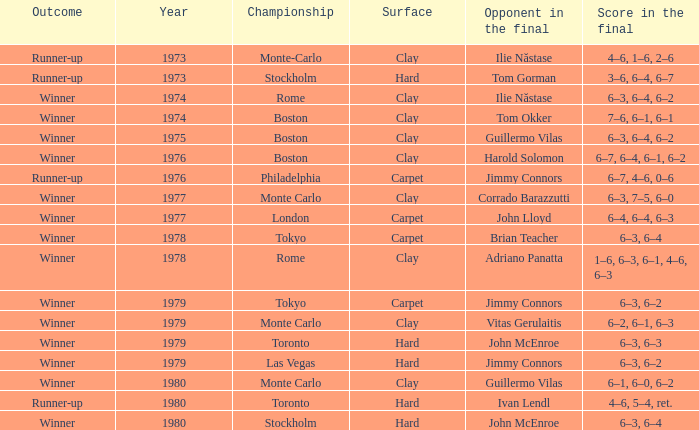Name the championship for clay and corrado barazzutti Monte Carlo. Help me parse the entirety of this table. {'header': ['Outcome', 'Year', 'Championship', 'Surface', 'Opponent in the final', 'Score in the final'], 'rows': [['Runner-up', '1973', 'Monte-Carlo', 'Clay', 'Ilie Năstase', '4–6, 1–6, 2–6'], ['Runner-up', '1973', 'Stockholm', 'Hard', 'Tom Gorman', '3–6, 6–4, 6–7'], ['Winner', '1974', 'Rome', 'Clay', 'Ilie Năstase', '6–3, 6–4, 6–2'], ['Winner', '1974', 'Boston', 'Clay', 'Tom Okker', '7–6, 6–1, 6–1'], ['Winner', '1975', 'Boston', 'Clay', 'Guillermo Vilas', '6–3, 6–4, 6–2'], ['Winner', '1976', 'Boston', 'Clay', 'Harold Solomon', '6–7, 6–4, 6–1, 6–2'], ['Runner-up', '1976', 'Philadelphia', 'Carpet', 'Jimmy Connors', '6–7, 4–6, 0–6'], ['Winner', '1977', 'Monte Carlo', 'Clay', 'Corrado Barazzutti', '6–3, 7–5, 6–0'], ['Winner', '1977', 'London', 'Carpet', 'John Lloyd', '6–4, 6–4, 6–3'], ['Winner', '1978', 'Tokyo', 'Carpet', 'Brian Teacher', '6–3, 6–4'], ['Winner', '1978', 'Rome', 'Clay', 'Adriano Panatta', '1–6, 6–3, 6–1, 4–6, 6–3'], ['Winner', '1979', 'Tokyo', 'Carpet', 'Jimmy Connors', '6–3, 6–2'], ['Winner', '1979', 'Monte Carlo', 'Clay', 'Vitas Gerulaitis', '6–2, 6–1, 6–3'], ['Winner', '1979', 'Toronto', 'Hard', 'John McEnroe', '6–3, 6–3'], ['Winner', '1979', 'Las Vegas', 'Hard', 'Jimmy Connors', '6–3, 6–2'], ['Winner', '1980', 'Monte Carlo', 'Clay', 'Guillermo Vilas', '6–1, 6–0, 6–2'], ['Runner-up', '1980', 'Toronto', 'Hard', 'Ivan Lendl', '4–6, 5–4, ret.'], ['Winner', '1980', 'Stockholm', 'Hard', 'John McEnroe', '6–3, 6–4']]} 